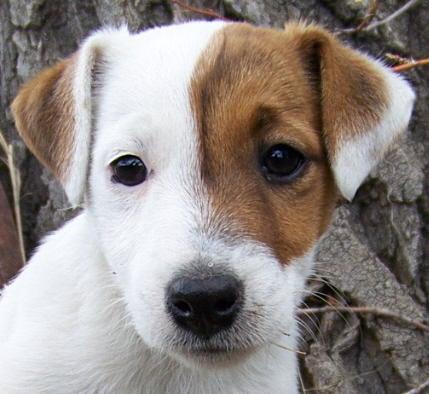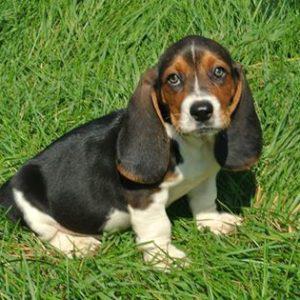The first image is the image on the left, the second image is the image on the right. Given the left and right images, does the statement "All the dogs are bloodhounds." hold true? Answer yes or no. No. 